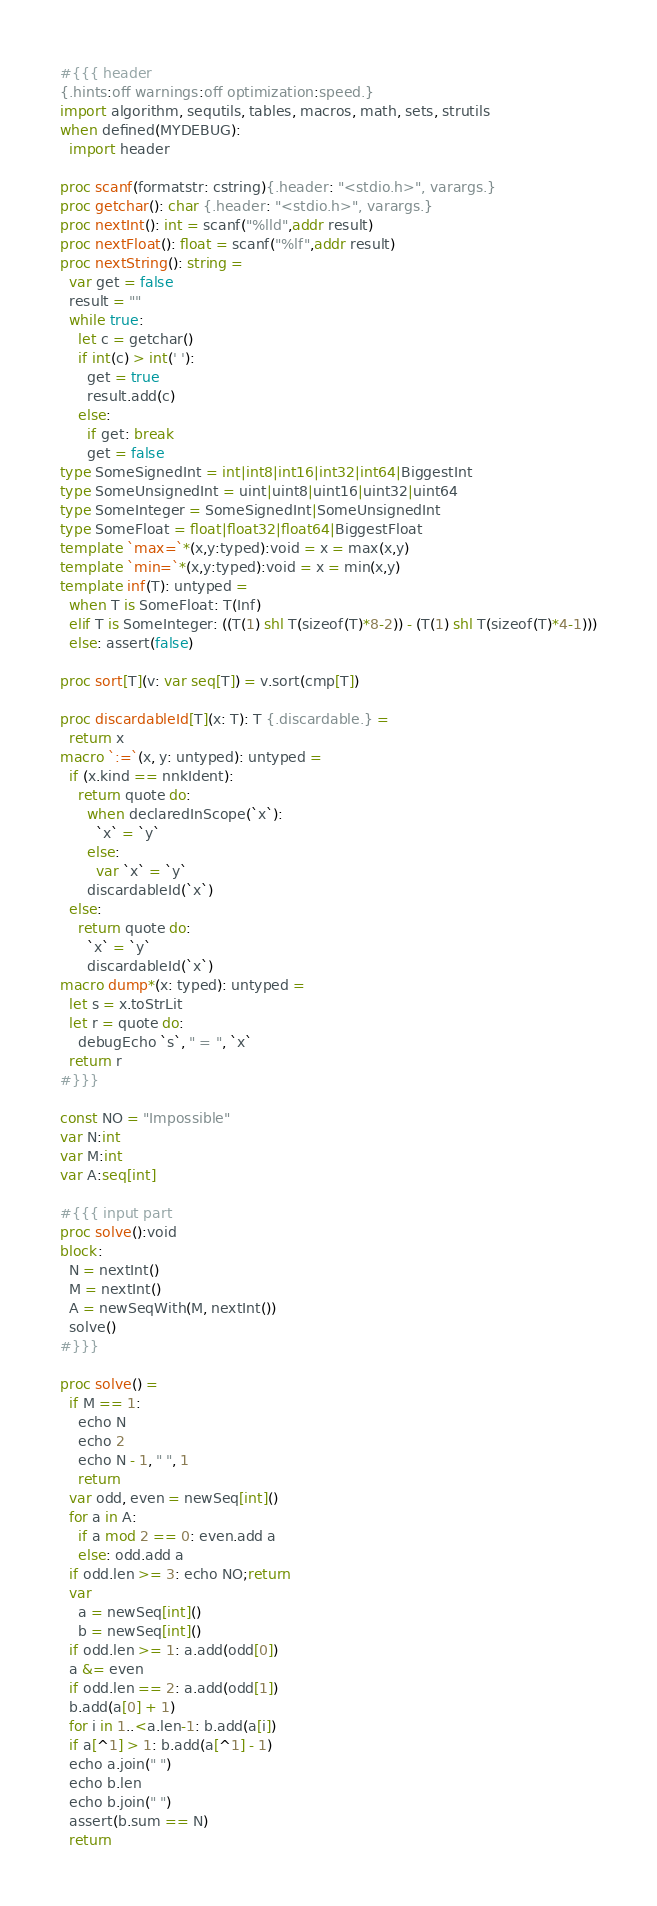Convert code to text. <code><loc_0><loc_0><loc_500><loc_500><_Nim_>#{{{ header
{.hints:off warnings:off optimization:speed.}
import algorithm, sequtils, tables, macros, math, sets, strutils
when defined(MYDEBUG):
  import header

proc scanf(formatstr: cstring){.header: "<stdio.h>", varargs.}
proc getchar(): char {.header: "<stdio.h>", varargs.}
proc nextInt(): int = scanf("%lld",addr result)
proc nextFloat(): float = scanf("%lf",addr result)
proc nextString(): string =
  var get = false
  result = ""
  while true:
    let c = getchar()
    if int(c) > int(' '):
      get = true
      result.add(c)
    else:
      if get: break
      get = false
type SomeSignedInt = int|int8|int16|int32|int64|BiggestInt
type SomeUnsignedInt = uint|uint8|uint16|uint32|uint64
type SomeInteger = SomeSignedInt|SomeUnsignedInt
type SomeFloat = float|float32|float64|BiggestFloat
template `max=`*(x,y:typed):void = x = max(x,y)
template `min=`*(x,y:typed):void = x = min(x,y)
template inf(T): untyped = 
  when T is SomeFloat: T(Inf)
  elif T is SomeInteger: ((T(1) shl T(sizeof(T)*8-2)) - (T(1) shl T(sizeof(T)*4-1)))
  else: assert(false)

proc sort[T](v: var seq[T]) = v.sort(cmp[T])

proc discardableId[T](x: T): T {.discardable.} =
  return x
macro `:=`(x, y: untyped): untyped =
  if (x.kind == nnkIdent):
    return quote do:
      when declaredInScope(`x`):
        `x` = `y`
      else:
        var `x` = `y`
      discardableId(`x`)
  else:
    return quote do:
      `x` = `y`
      discardableId(`x`)
macro dump*(x: typed): untyped =
  let s = x.toStrLit
  let r = quote do:
    debugEcho `s`, " = ", `x`
  return r
#}}}

const NO = "Impossible"
var N:int
var M:int
var A:seq[int]

#{{{ input part
proc solve():void
block:
  N = nextInt()
  M = nextInt()
  A = newSeqWith(M, nextInt())
  solve()
#}}}

proc solve() =
  if M == 1:
    echo N
    echo 2
    echo N - 1, " ", 1
    return
  var odd, even = newSeq[int]()
  for a in A:
    if a mod 2 == 0: even.add a
    else: odd.add a
  if odd.len >= 3: echo NO;return
  var
    a = newSeq[int]()
    b = newSeq[int]()
  if odd.len >= 1: a.add(odd[0])
  a &= even
  if odd.len == 2: a.add(odd[1])
  b.add(a[0] + 1)
  for i in 1..<a.len-1: b.add(a[i])
  if a[^1] > 1: b.add(a[^1] - 1)
  echo a.join(" ")
  echo b.len
  echo b.join(" ")
  assert(b.sum == N)
  return</code> 